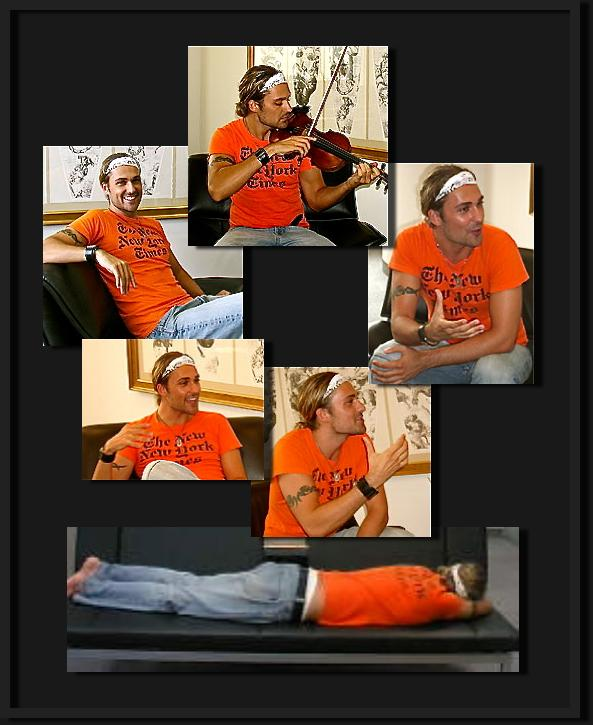How does playing the violin contribute to the atmosphere of the event the man is attending? Playing the violin contributes significantly to the social ambiance of the event, adding a melodious background that likely encourages interaction, provides entertainment, and enhances the creative vibe. It might also induce a sense of community as participants appreciate or join in the musical experience. 